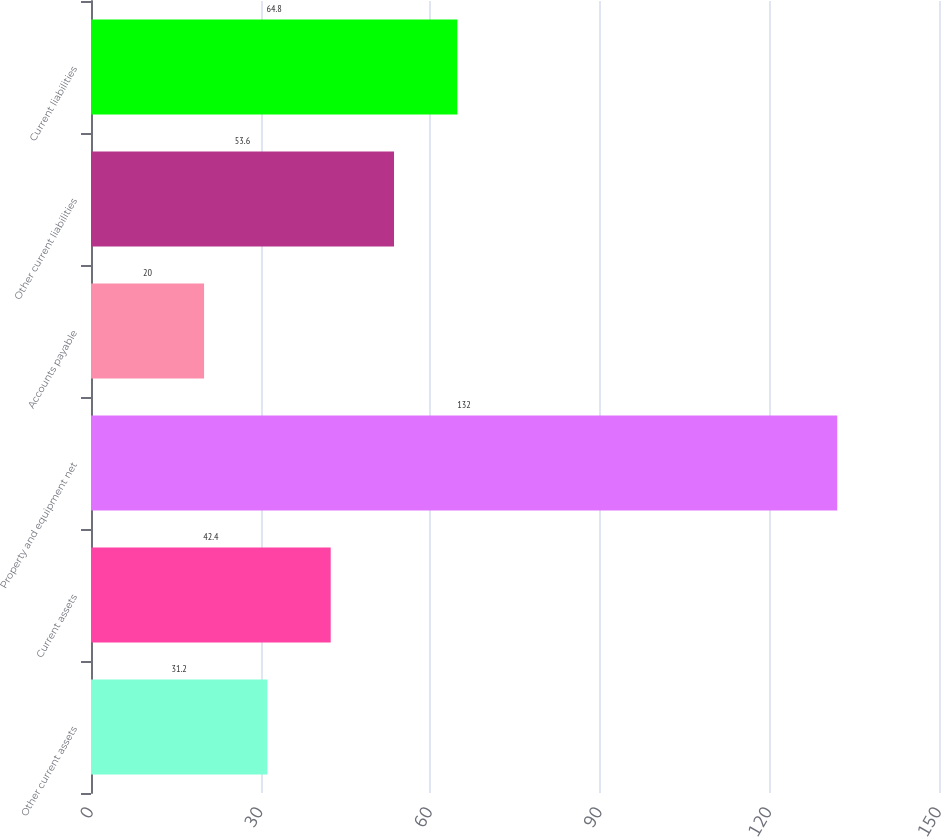Convert chart to OTSL. <chart><loc_0><loc_0><loc_500><loc_500><bar_chart><fcel>Other current assets<fcel>Current assets<fcel>Property and equipment net<fcel>Accounts payable<fcel>Other current liabilities<fcel>Current liabilities<nl><fcel>31.2<fcel>42.4<fcel>132<fcel>20<fcel>53.6<fcel>64.8<nl></chart> 